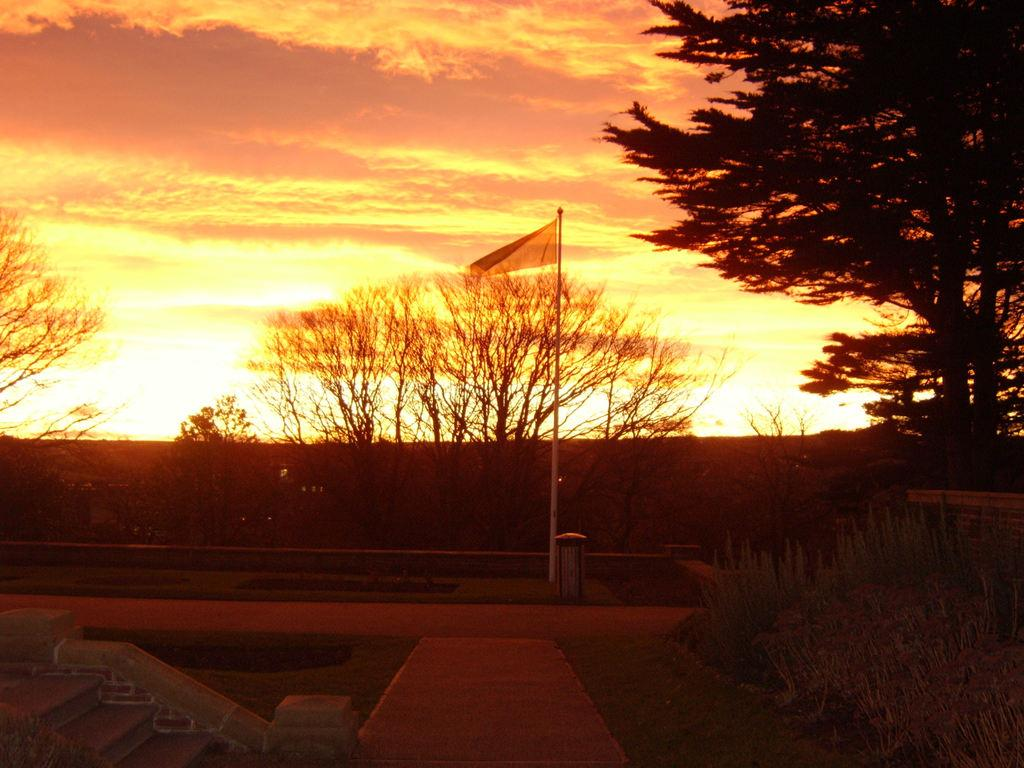What is on the pole in the image? There is a flag on a pole in the image. What architectural feature can be seen in the image? There is a staircase in the image. What type of surface is visible in the image? There is a pathway in the image. What type of vegetation is present in the image? There are plants and a group of trees in the image. What type of ground cover is visible in the image? There is grass in the image. What is the condition of the sky in the image? The sky is visible in the image, and it appears cloudy. What is the rate at which the trucks are moving in the image? There are no trucks present in the image, so it is not possible to determine their rate of movement. What type of hammer is being used to maintain the plants in the image? There is no hammer present in the image, and the plants do not require maintenance in this context. 